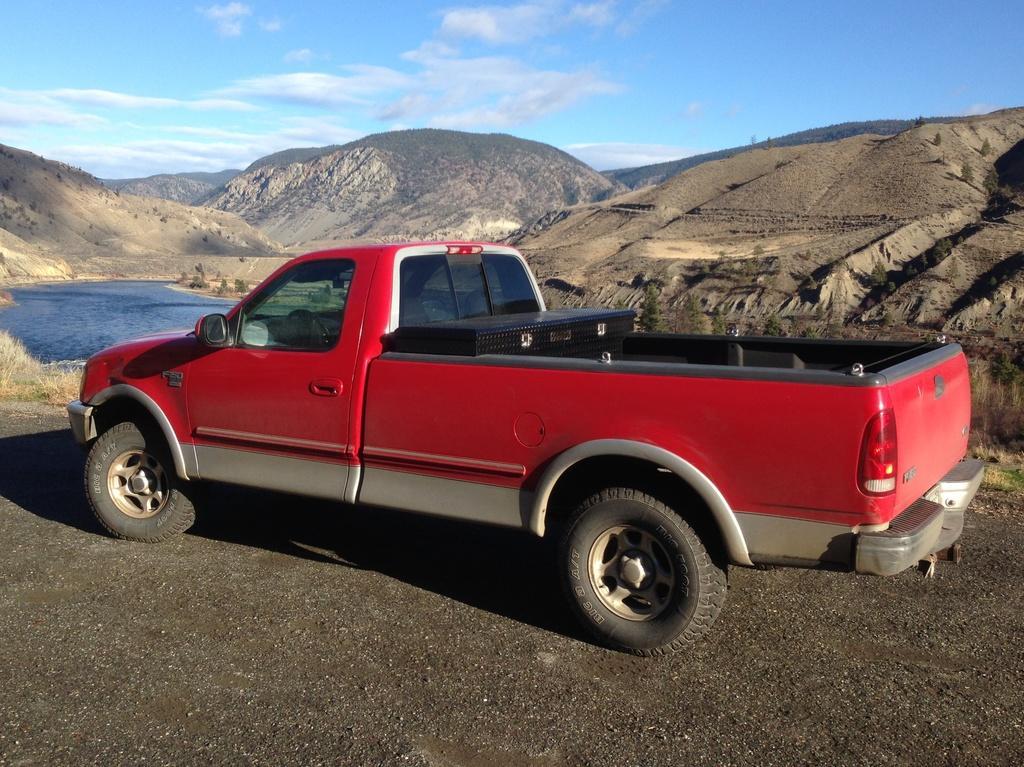Describe this image in one or two sentences. In this picture there is a red color car which is park on the road. On the background we can see many mountains. On the top we can see sky and clouds. On the left there is a water. Here we can see grass. 